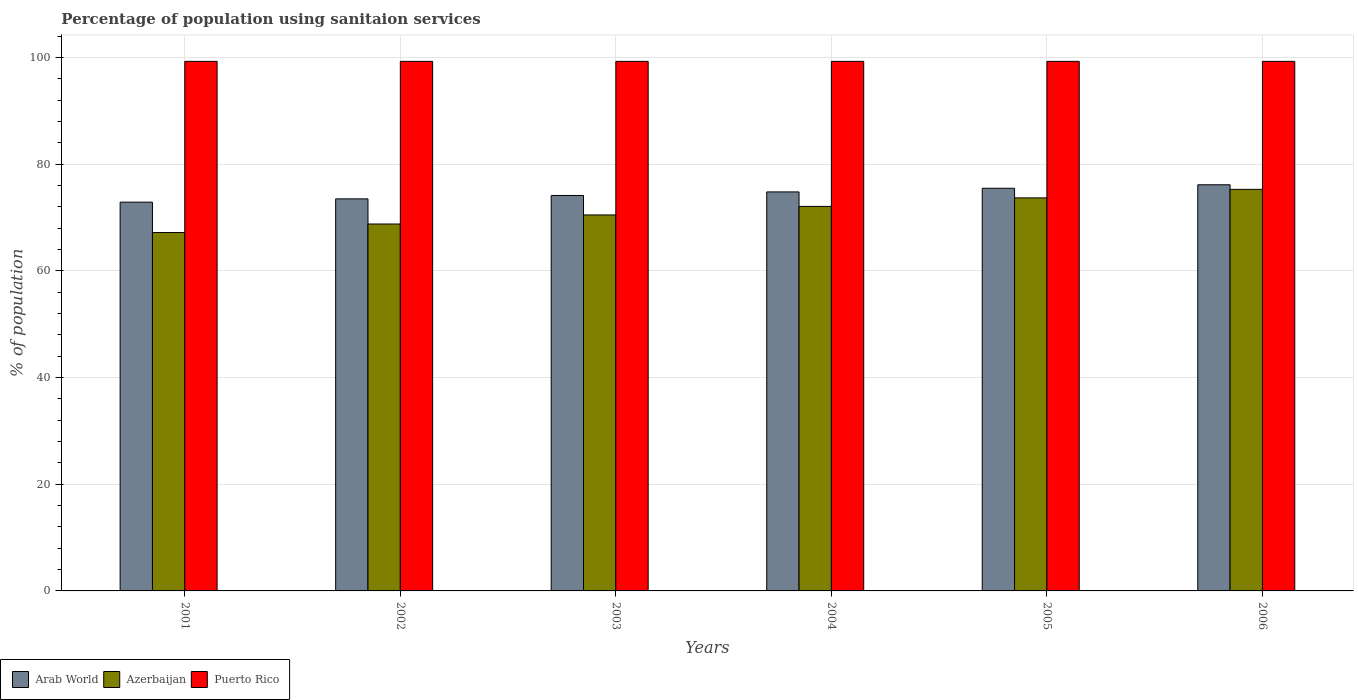How many different coloured bars are there?
Your response must be concise. 3. How many groups of bars are there?
Offer a very short reply. 6. Are the number of bars per tick equal to the number of legend labels?
Your answer should be compact. Yes. In how many cases, is the number of bars for a given year not equal to the number of legend labels?
Offer a terse response. 0. What is the percentage of population using sanitaion services in Arab World in 2005?
Keep it short and to the point. 75.5. Across all years, what is the maximum percentage of population using sanitaion services in Puerto Rico?
Make the answer very short. 99.3. Across all years, what is the minimum percentage of population using sanitaion services in Arab World?
Your answer should be compact. 72.9. In which year was the percentage of population using sanitaion services in Arab World minimum?
Ensure brevity in your answer.  2001. What is the total percentage of population using sanitaion services in Azerbaijan in the graph?
Your answer should be very brief. 427.6. What is the difference between the percentage of population using sanitaion services in Arab World in 2004 and that in 2006?
Offer a terse response. -1.34. What is the difference between the percentage of population using sanitaion services in Puerto Rico in 2005 and the percentage of population using sanitaion services in Arab World in 2001?
Your response must be concise. 26.4. What is the average percentage of population using sanitaion services in Arab World per year?
Your answer should be very brief. 74.51. In the year 2004, what is the difference between the percentage of population using sanitaion services in Puerto Rico and percentage of population using sanitaion services in Arab World?
Offer a terse response. 24.48. In how many years, is the percentage of population using sanitaion services in Puerto Rico greater than 36 %?
Your response must be concise. 6. What is the ratio of the percentage of population using sanitaion services in Azerbaijan in 2003 to that in 2005?
Your answer should be compact. 0.96. What is the difference between the highest and the second highest percentage of population using sanitaion services in Azerbaijan?
Ensure brevity in your answer.  1.6. What is the difference between the highest and the lowest percentage of population using sanitaion services in Arab World?
Provide a succinct answer. 3.26. Is the sum of the percentage of population using sanitaion services in Arab World in 2003 and 2004 greater than the maximum percentage of population using sanitaion services in Azerbaijan across all years?
Offer a very short reply. Yes. What does the 3rd bar from the left in 2005 represents?
Offer a very short reply. Puerto Rico. What does the 2nd bar from the right in 2003 represents?
Offer a terse response. Azerbaijan. Is it the case that in every year, the sum of the percentage of population using sanitaion services in Puerto Rico and percentage of population using sanitaion services in Arab World is greater than the percentage of population using sanitaion services in Azerbaijan?
Offer a very short reply. Yes. How many years are there in the graph?
Your answer should be compact. 6. How are the legend labels stacked?
Offer a very short reply. Horizontal. What is the title of the graph?
Ensure brevity in your answer.  Percentage of population using sanitaion services. What is the label or title of the Y-axis?
Your answer should be compact. % of population. What is the % of population in Arab World in 2001?
Your response must be concise. 72.9. What is the % of population of Azerbaijan in 2001?
Provide a short and direct response. 67.2. What is the % of population of Puerto Rico in 2001?
Provide a short and direct response. 99.3. What is the % of population in Arab World in 2002?
Offer a very short reply. 73.51. What is the % of population in Azerbaijan in 2002?
Your response must be concise. 68.8. What is the % of population in Puerto Rico in 2002?
Make the answer very short. 99.3. What is the % of population in Arab World in 2003?
Your answer should be very brief. 74.15. What is the % of population in Azerbaijan in 2003?
Keep it short and to the point. 70.5. What is the % of population of Puerto Rico in 2003?
Keep it short and to the point. 99.3. What is the % of population in Arab World in 2004?
Give a very brief answer. 74.82. What is the % of population of Azerbaijan in 2004?
Offer a terse response. 72.1. What is the % of population in Puerto Rico in 2004?
Your answer should be compact. 99.3. What is the % of population of Arab World in 2005?
Your response must be concise. 75.5. What is the % of population of Azerbaijan in 2005?
Your answer should be very brief. 73.7. What is the % of population in Puerto Rico in 2005?
Make the answer very short. 99.3. What is the % of population in Arab World in 2006?
Your response must be concise. 76.16. What is the % of population in Azerbaijan in 2006?
Keep it short and to the point. 75.3. What is the % of population of Puerto Rico in 2006?
Offer a terse response. 99.3. Across all years, what is the maximum % of population in Arab World?
Provide a succinct answer. 76.16. Across all years, what is the maximum % of population of Azerbaijan?
Offer a terse response. 75.3. Across all years, what is the maximum % of population in Puerto Rico?
Your answer should be compact. 99.3. Across all years, what is the minimum % of population in Arab World?
Provide a short and direct response. 72.9. Across all years, what is the minimum % of population of Azerbaijan?
Ensure brevity in your answer.  67.2. Across all years, what is the minimum % of population of Puerto Rico?
Offer a very short reply. 99.3. What is the total % of population of Arab World in the graph?
Your answer should be very brief. 447.04. What is the total % of population in Azerbaijan in the graph?
Your answer should be very brief. 427.6. What is the total % of population in Puerto Rico in the graph?
Give a very brief answer. 595.8. What is the difference between the % of population in Arab World in 2001 and that in 2002?
Ensure brevity in your answer.  -0.62. What is the difference between the % of population in Arab World in 2001 and that in 2003?
Give a very brief answer. -1.25. What is the difference between the % of population in Puerto Rico in 2001 and that in 2003?
Ensure brevity in your answer.  0. What is the difference between the % of population in Arab World in 2001 and that in 2004?
Make the answer very short. -1.92. What is the difference between the % of population in Azerbaijan in 2001 and that in 2004?
Provide a short and direct response. -4.9. What is the difference between the % of population of Arab World in 2001 and that in 2005?
Your response must be concise. -2.61. What is the difference between the % of population of Arab World in 2001 and that in 2006?
Give a very brief answer. -3.26. What is the difference between the % of population in Azerbaijan in 2001 and that in 2006?
Your response must be concise. -8.1. What is the difference between the % of population in Puerto Rico in 2001 and that in 2006?
Offer a very short reply. 0. What is the difference between the % of population in Arab World in 2002 and that in 2003?
Your answer should be very brief. -0.64. What is the difference between the % of population in Arab World in 2002 and that in 2004?
Provide a short and direct response. -1.3. What is the difference between the % of population in Puerto Rico in 2002 and that in 2004?
Give a very brief answer. 0. What is the difference between the % of population in Arab World in 2002 and that in 2005?
Offer a very short reply. -1.99. What is the difference between the % of population in Azerbaijan in 2002 and that in 2005?
Keep it short and to the point. -4.9. What is the difference between the % of population in Arab World in 2002 and that in 2006?
Offer a terse response. -2.64. What is the difference between the % of population of Azerbaijan in 2002 and that in 2006?
Keep it short and to the point. -6.5. What is the difference between the % of population of Arab World in 2003 and that in 2004?
Keep it short and to the point. -0.67. What is the difference between the % of population in Azerbaijan in 2003 and that in 2004?
Ensure brevity in your answer.  -1.6. What is the difference between the % of population of Arab World in 2003 and that in 2005?
Offer a terse response. -1.35. What is the difference between the % of population in Arab World in 2003 and that in 2006?
Offer a terse response. -2.01. What is the difference between the % of population of Azerbaijan in 2003 and that in 2006?
Make the answer very short. -4.8. What is the difference between the % of population of Arab World in 2004 and that in 2005?
Provide a succinct answer. -0.69. What is the difference between the % of population of Azerbaijan in 2004 and that in 2005?
Your answer should be very brief. -1.6. What is the difference between the % of population of Arab World in 2004 and that in 2006?
Make the answer very short. -1.34. What is the difference between the % of population of Azerbaijan in 2004 and that in 2006?
Your response must be concise. -3.2. What is the difference between the % of population of Puerto Rico in 2004 and that in 2006?
Your answer should be very brief. 0. What is the difference between the % of population in Arab World in 2005 and that in 2006?
Offer a terse response. -0.65. What is the difference between the % of population in Arab World in 2001 and the % of population in Azerbaijan in 2002?
Offer a very short reply. 4.1. What is the difference between the % of population of Arab World in 2001 and the % of population of Puerto Rico in 2002?
Offer a terse response. -26.4. What is the difference between the % of population of Azerbaijan in 2001 and the % of population of Puerto Rico in 2002?
Keep it short and to the point. -32.1. What is the difference between the % of population of Arab World in 2001 and the % of population of Azerbaijan in 2003?
Provide a succinct answer. 2.4. What is the difference between the % of population of Arab World in 2001 and the % of population of Puerto Rico in 2003?
Give a very brief answer. -26.4. What is the difference between the % of population of Azerbaijan in 2001 and the % of population of Puerto Rico in 2003?
Keep it short and to the point. -32.1. What is the difference between the % of population in Arab World in 2001 and the % of population in Azerbaijan in 2004?
Your answer should be compact. 0.8. What is the difference between the % of population of Arab World in 2001 and the % of population of Puerto Rico in 2004?
Ensure brevity in your answer.  -26.4. What is the difference between the % of population of Azerbaijan in 2001 and the % of population of Puerto Rico in 2004?
Give a very brief answer. -32.1. What is the difference between the % of population of Arab World in 2001 and the % of population of Azerbaijan in 2005?
Give a very brief answer. -0.8. What is the difference between the % of population of Arab World in 2001 and the % of population of Puerto Rico in 2005?
Make the answer very short. -26.4. What is the difference between the % of population of Azerbaijan in 2001 and the % of population of Puerto Rico in 2005?
Provide a short and direct response. -32.1. What is the difference between the % of population in Arab World in 2001 and the % of population in Azerbaijan in 2006?
Provide a short and direct response. -2.4. What is the difference between the % of population in Arab World in 2001 and the % of population in Puerto Rico in 2006?
Offer a terse response. -26.4. What is the difference between the % of population of Azerbaijan in 2001 and the % of population of Puerto Rico in 2006?
Offer a terse response. -32.1. What is the difference between the % of population of Arab World in 2002 and the % of population of Azerbaijan in 2003?
Your response must be concise. 3.01. What is the difference between the % of population in Arab World in 2002 and the % of population in Puerto Rico in 2003?
Offer a very short reply. -25.79. What is the difference between the % of population of Azerbaijan in 2002 and the % of population of Puerto Rico in 2003?
Make the answer very short. -30.5. What is the difference between the % of population of Arab World in 2002 and the % of population of Azerbaijan in 2004?
Keep it short and to the point. 1.41. What is the difference between the % of population of Arab World in 2002 and the % of population of Puerto Rico in 2004?
Keep it short and to the point. -25.79. What is the difference between the % of population of Azerbaijan in 2002 and the % of population of Puerto Rico in 2004?
Your answer should be compact. -30.5. What is the difference between the % of population in Arab World in 2002 and the % of population in Azerbaijan in 2005?
Provide a succinct answer. -0.19. What is the difference between the % of population in Arab World in 2002 and the % of population in Puerto Rico in 2005?
Offer a very short reply. -25.79. What is the difference between the % of population of Azerbaijan in 2002 and the % of population of Puerto Rico in 2005?
Keep it short and to the point. -30.5. What is the difference between the % of population of Arab World in 2002 and the % of population of Azerbaijan in 2006?
Make the answer very short. -1.79. What is the difference between the % of population of Arab World in 2002 and the % of population of Puerto Rico in 2006?
Keep it short and to the point. -25.79. What is the difference between the % of population in Azerbaijan in 2002 and the % of population in Puerto Rico in 2006?
Offer a terse response. -30.5. What is the difference between the % of population of Arab World in 2003 and the % of population of Azerbaijan in 2004?
Provide a short and direct response. 2.05. What is the difference between the % of population in Arab World in 2003 and the % of population in Puerto Rico in 2004?
Give a very brief answer. -25.15. What is the difference between the % of population of Azerbaijan in 2003 and the % of population of Puerto Rico in 2004?
Offer a terse response. -28.8. What is the difference between the % of population of Arab World in 2003 and the % of population of Azerbaijan in 2005?
Your response must be concise. 0.45. What is the difference between the % of population in Arab World in 2003 and the % of population in Puerto Rico in 2005?
Provide a succinct answer. -25.15. What is the difference between the % of population in Azerbaijan in 2003 and the % of population in Puerto Rico in 2005?
Keep it short and to the point. -28.8. What is the difference between the % of population in Arab World in 2003 and the % of population in Azerbaijan in 2006?
Keep it short and to the point. -1.15. What is the difference between the % of population of Arab World in 2003 and the % of population of Puerto Rico in 2006?
Your response must be concise. -25.15. What is the difference between the % of population in Azerbaijan in 2003 and the % of population in Puerto Rico in 2006?
Your response must be concise. -28.8. What is the difference between the % of population in Arab World in 2004 and the % of population in Azerbaijan in 2005?
Your answer should be compact. 1.12. What is the difference between the % of population in Arab World in 2004 and the % of population in Puerto Rico in 2005?
Offer a terse response. -24.48. What is the difference between the % of population of Azerbaijan in 2004 and the % of population of Puerto Rico in 2005?
Provide a short and direct response. -27.2. What is the difference between the % of population in Arab World in 2004 and the % of population in Azerbaijan in 2006?
Offer a very short reply. -0.48. What is the difference between the % of population in Arab World in 2004 and the % of population in Puerto Rico in 2006?
Provide a short and direct response. -24.48. What is the difference between the % of population of Azerbaijan in 2004 and the % of population of Puerto Rico in 2006?
Your answer should be compact. -27.2. What is the difference between the % of population in Arab World in 2005 and the % of population in Azerbaijan in 2006?
Make the answer very short. 0.2. What is the difference between the % of population in Arab World in 2005 and the % of population in Puerto Rico in 2006?
Offer a very short reply. -23.8. What is the difference between the % of population in Azerbaijan in 2005 and the % of population in Puerto Rico in 2006?
Ensure brevity in your answer.  -25.6. What is the average % of population in Arab World per year?
Give a very brief answer. 74.51. What is the average % of population of Azerbaijan per year?
Your answer should be compact. 71.27. What is the average % of population in Puerto Rico per year?
Keep it short and to the point. 99.3. In the year 2001, what is the difference between the % of population of Arab World and % of population of Azerbaijan?
Make the answer very short. 5.7. In the year 2001, what is the difference between the % of population of Arab World and % of population of Puerto Rico?
Provide a short and direct response. -26.4. In the year 2001, what is the difference between the % of population in Azerbaijan and % of population in Puerto Rico?
Give a very brief answer. -32.1. In the year 2002, what is the difference between the % of population in Arab World and % of population in Azerbaijan?
Provide a short and direct response. 4.71. In the year 2002, what is the difference between the % of population of Arab World and % of population of Puerto Rico?
Make the answer very short. -25.79. In the year 2002, what is the difference between the % of population in Azerbaijan and % of population in Puerto Rico?
Your response must be concise. -30.5. In the year 2003, what is the difference between the % of population of Arab World and % of population of Azerbaijan?
Make the answer very short. 3.65. In the year 2003, what is the difference between the % of population in Arab World and % of population in Puerto Rico?
Provide a succinct answer. -25.15. In the year 2003, what is the difference between the % of population in Azerbaijan and % of population in Puerto Rico?
Make the answer very short. -28.8. In the year 2004, what is the difference between the % of population in Arab World and % of population in Azerbaijan?
Make the answer very short. 2.72. In the year 2004, what is the difference between the % of population of Arab World and % of population of Puerto Rico?
Provide a short and direct response. -24.48. In the year 2004, what is the difference between the % of population of Azerbaijan and % of population of Puerto Rico?
Your response must be concise. -27.2. In the year 2005, what is the difference between the % of population of Arab World and % of population of Azerbaijan?
Give a very brief answer. 1.8. In the year 2005, what is the difference between the % of population of Arab World and % of population of Puerto Rico?
Give a very brief answer. -23.8. In the year 2005, what is the difference between the % of population of Azerbaijan and % of population of Puerto Rico?
Your answer should be very brief. -25.6. In the year 2006, what is the difference between the % of population of Arab World and % of population of Azerbaijan?
Give a very brief answer. 0.86. In the year 2006, what is the difference between the % of population of Arab World and % of population of Puerto Rico?
Provide a succinct answer. -23.14. In the year 2006, what is the difference between the % of population in Azerbaijan and % of population in Puerto Rico?
Your response must be concise. -24. What is the ratio of the % of population in Arab World in 2001 to that in 2002?
Keep it short and to the point. 0.99. What is the ratio of the % of population in Azerbaijan in 2001 to that in 2002?
Ensure brevity in your answer.  0.98. What is the ratio of the % of population in Arab World in 2001 to that in 2003?
Provide a short and direct response. 0.98. What is the ratio of the % of population of Azerbaijan in 2001 to that in 2003?
Provide a succinct answer. 0.95. What is the ratio of the % of population of Arab World in 2001 to that in 2004?
Provide a succinct answer. 0.97. What is the ratio of the % of population in Azerbaijan in 2001 to that in 2004?
Your response must be concise. 0.93. What is the ratio of the % of population of Arab World in 2001 to that in 2005?
Give a very brief answer. 0.97. What is the ratio of the % of population in Azerbaijan in 2001 to that in 2005?
Give a very brief answer. 0.91. What is the ratio of the % of population of Arab World in 2001 to that in 2006?
Ensure brevity in your answer.  0.96. What is the ratio of the % of population of Azerbaijan in 2001 to that in 2006?
Your answer should be compact. 0.89. What is the ratio of the % of population of Azerbaijan in 2002 to that in 2003?
Keep it short and to the point. 0.98. What is the ratio of the % of population of Arab World in 2002 to that in 2004?
Keep it short and to the point. 0.98. What is the ratio of the % of population in Azerbaijan in 2002 to that in 2004?
Your answer should be very brief. 0.95. What is the ratio of the % of population in Puerto Rico in 2002 to that in 2004?
Your response must be concise. 1. What is the ratio of the % of population of Arab World in 2002 to that in 2005?
Your answer should be very brief. 0.97. What is the ratio of the % of population of Azerbaijan in 2002 to that in 2005?
Make the answer very short. 0.93. What is the ratio of the % of population of Arab World in 2002 to that in 2006?
Your answer should be compact. 0.97. What is the ratio of the % of population of Azerbaijan in 2002 to that in 2006?
Provide a succinct answer. 0.91. What is the ratio of the % of population of Azerbaijan in 2003 to that in 2004?
Give a very brief answer. 0.98. What is the ratio of the % of population of Arab World in 2003 to that in 2005?
Keep it short and to the point. 0.98. What is the ratio of the % of population in Azerbaijan in 2003 to that in 2005?
Provide a succinct answer. 0.96. What is the ratio of the % of population of Puerto Rico in 2003 to that in 2005?
Keep it short and to the point. 1. What is the ratio of the % of population of Arab World in 2003 to that in 2006?
Keep it short and to the point. 0.97. What is the ratio of the % of population in Azerbaijan in 2003 to that in 2006?
Make the answer very short. 0.94. What is the ratio of the % of population of Arab World in 2004 to that in 2005?
Your response must be concise. 0.99. What is the ratio of the % of population in Azerbaijan in 2004 to that in 2005?
Offer a terse response. 0.98. What is the ratio of the % of population in Puerto Rico in 2004 to that in 2005?
Your answer should be very brief. 1. What is the ratio of the % of population of Arab World in 2004 to that in 2006?
Your answer should be very brief. 0.98. What is the ratio of the % of population in Azerbaijan in 2004 to that in 2006?
Offer a terse response. 0.96. What is the ratio of the % of population of Azerbaijan in 2005 to that in 2006?
Your answer should be very brief. 0.98. What is the ratio of the % of population in Puerto Rico in 2005 to that in 2006?
Your answer should be very brief. 1. What is the difference between the highest and the second highest % of population in Arab World?
Give a very brief answer. 0.65. What is the difference between the highest and the second highest % of population of Azerbaijan?
Give a very brief answer. 1.6. What is the difference between the highest and the lowest % of population of Arab World?
Make the answer very short. 3.26. What is the difference between the highest and the lowest % of population of Puerto Rico?
Keep it short and to the point. 0. 